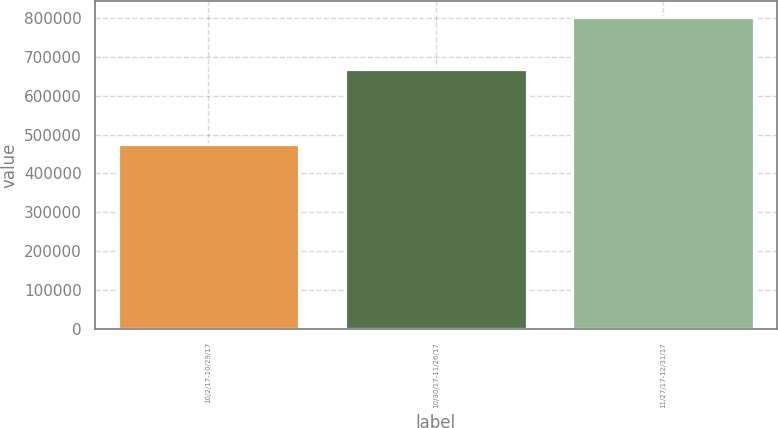Convert chart. <chart><loc_0><loc_0><loc_500><loc_500><bar_chart><fcel>10/2/17-10/29/17<fcel>10/30/17-11/26/17<fcel>11/27/17-12/31/17<nl><fcel>475000<fcel>669835<fcel>803451<nl></chart> 